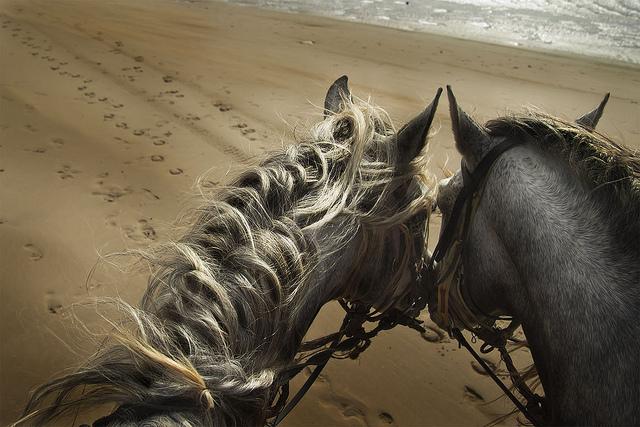What animals are they?
Answer briefly. Horses. What type of footprints are in the sand?
Short answer required. Horse. Are the animals close to each other?
Be succinct. Yes. 